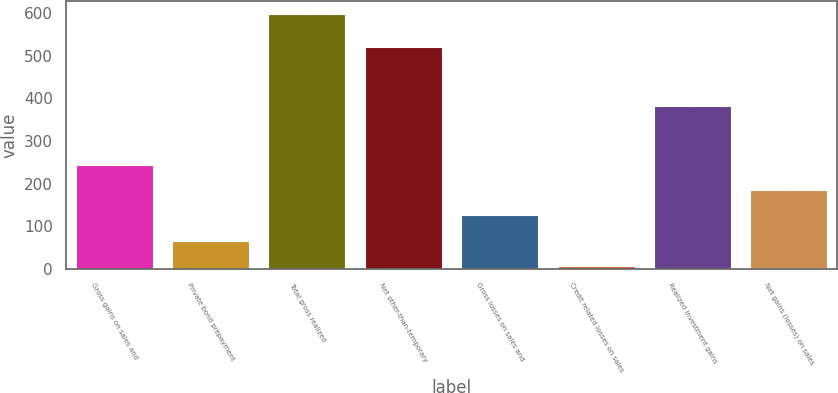<chart> <loc_0><loc_0><loc_500><loc_500><bar_chart><fcel>Gross gains on sales and<fcel>Private bond prepayment<fcel>Total gross realized<fcel>Net other-than-temporary<fcel>Gross losses on sales and<fcel>Credit related losses on sales<fcel>Realized investment gains<fcel>Net gains (losses) on sales<nl><fcel>243.8<fcel>66.2<fcel>599<fcel>520<fcel>125.4<fcel>7<fcel>381<fcel>184.6<nl></chart> 